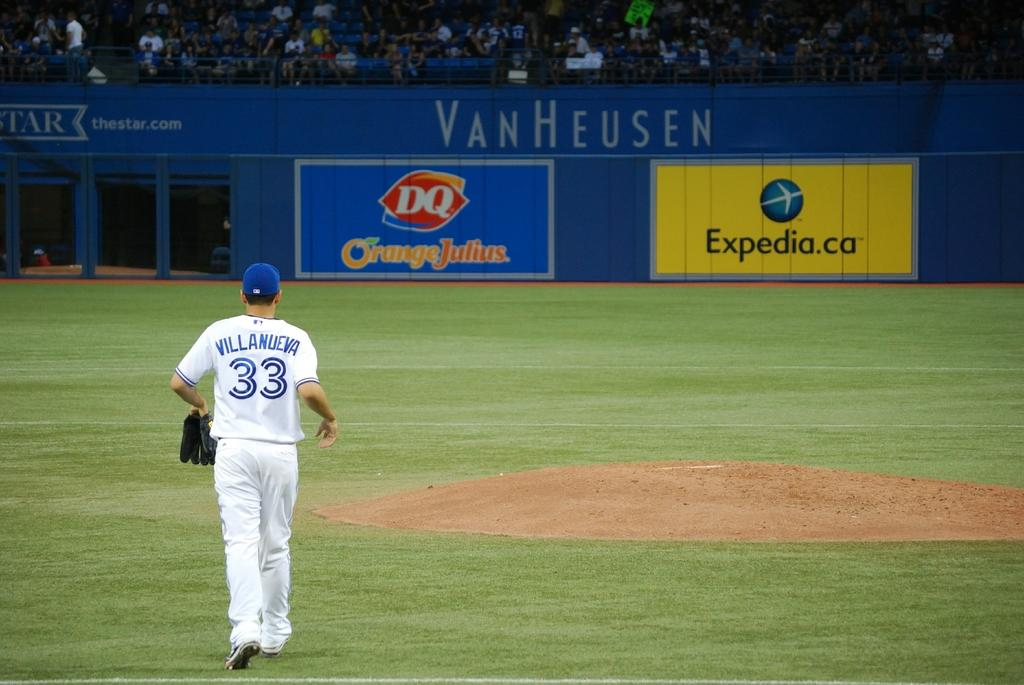<image>
Describe the image concisely. Baseball player Villanueva is walking on a field that has a VanHeusen banner on it. 